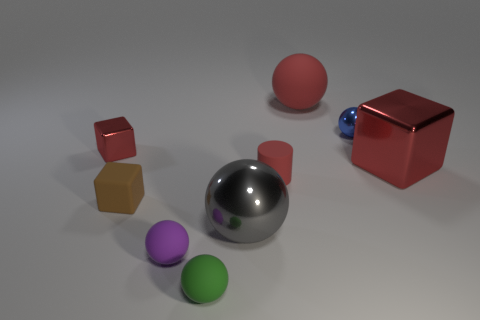Subtract 2 spheres. How many spheres are left? 3 Subtract all cyan balls. Subtract all red cubes. How many balls are left? 5 Subtract all cylinders. How many objects are left? 8 Add 5 tiny cyan metallic cylinders. How many tiny cyan metallic cylinders exist? 5 Subtract 0 brown cylinders. How many objects are left? 9 Subtract all large purple rubber spheres. Subtract all small cubes. How many objects are left? 7 Add 2 gray metallic balls. How many gray metallic balls are left? 3 